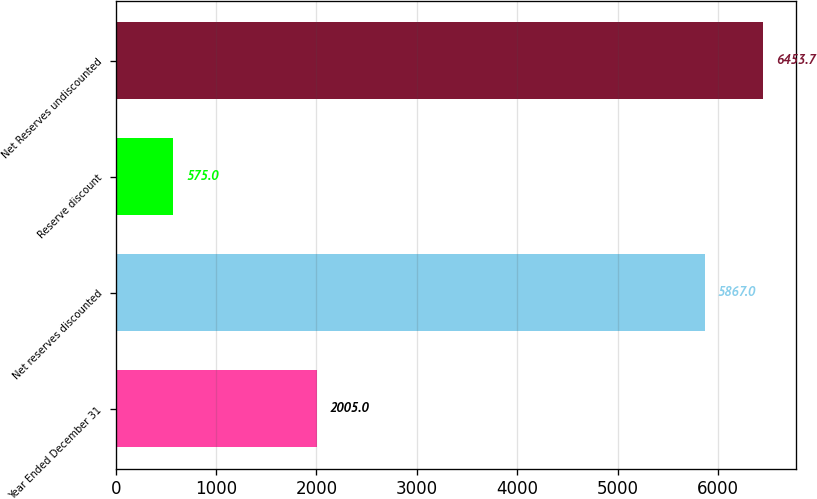Convert chart to OTSL. <chart><loc_0><loc_0><loc_500><loc_500><bar_chart><fcel>Year Ended December 31<fcel>Net reserves discounted<fcel>Reserve discount<fcel>Net Reserves undiscounted<nl><fcel>2005<fcel>5867<fcel>575<fcel>6453.7<nl></chart> 